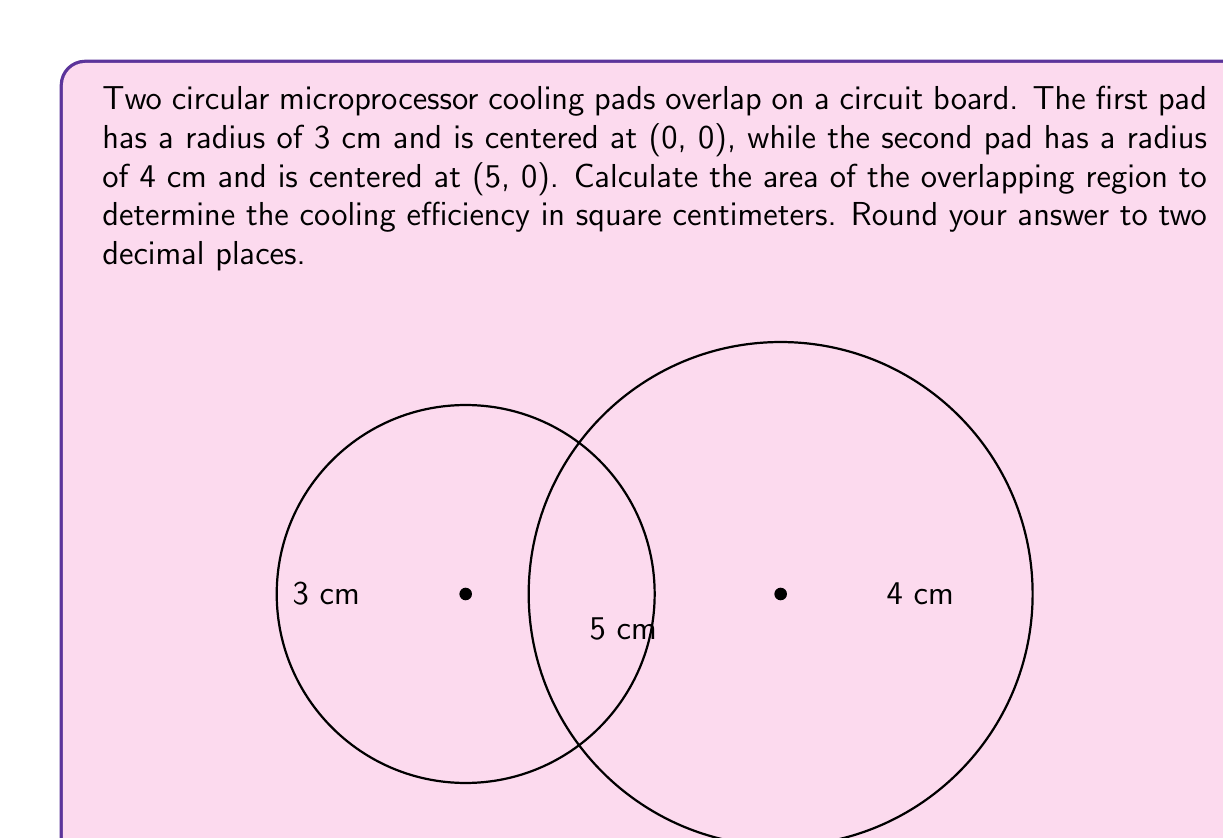Show me your answer to this math problem. Let's approach this step-by-step:

1) First, we need to find the distance between the centers of the circles. This is given as 5 cm.

2) The area of intersection of two circles can be calculated using the formula:

   $$A = r_1^2 \arccos\left(\frac{d^2 + r_1^2 - r_2^2}{2dr_1}\right) + r_2^2 \arccos\left(\frac{d^2 + r_2^2 - r_1^2}{2dr_2}\right) - \frac{1}{2}\sqrt{(-d+r_1+r_2)(d+r_1-r_2)(d-r_1+r_2)(d+r_1+r_2)}$$

   Where $r_1$ and $r_2$ are the radii of the circles, and $d$ is the distance between their centers.

3) Let's substitute our values:
   $r_1 = 3$, $r_2 = 4$, $d = 5$

4) Calculating each part:

   $$\arccos\left(\frac{5^2 + 3^2 - 4^2}{2 * 5 * 3}\right) = \arccos(0.5833) = 0.9553$$
   $$\arccos\left(\frac{5^2 + 4^2 - 3^2}{2 * 5 * 4}\right) = \arccos(0.6875) = 0.8085$$
   $$\sqrt{(-5+3+4)(5+3-4)(5-3+4)(5+3+4)} = \sqrt{2 * 4 * 6 * 12} = 12$$

5) Putting it all together:

   $$A = 3^2 * 0.9553 + 4^2 * 0.8085 - \frac{1}{2} * 12$$
   $$A = 8.5977 + 12.936 - 6 = 15.5337$$

6) Rounding to two decimal places:
   $A \approx 15.53$ cm²
Answer: 15.53 cm² 